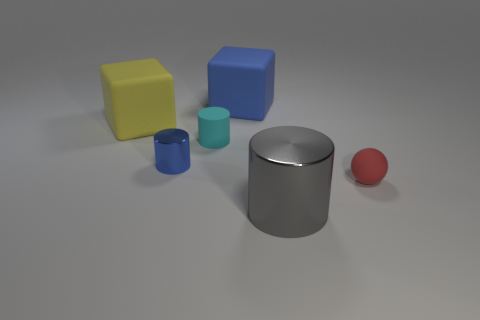Subtract all tiny matte cylinders. How many cylinders are left? 2 Add 3 big blue rubber blocks. How many objects exist? 9 Subtract all cubes. How many objects are left? 4 Subtract all yellow metallic things. Subtract all red rubber balls. How many objects are left? 5 Add 1 big yellow matte blocks. How many big yellow matte blocks are left? 2 Add 5 gray shiny cylinders. How many gray shiny cylinders exist? 6 Subtract 1 cyan cylinders. How many objects are left? 5 